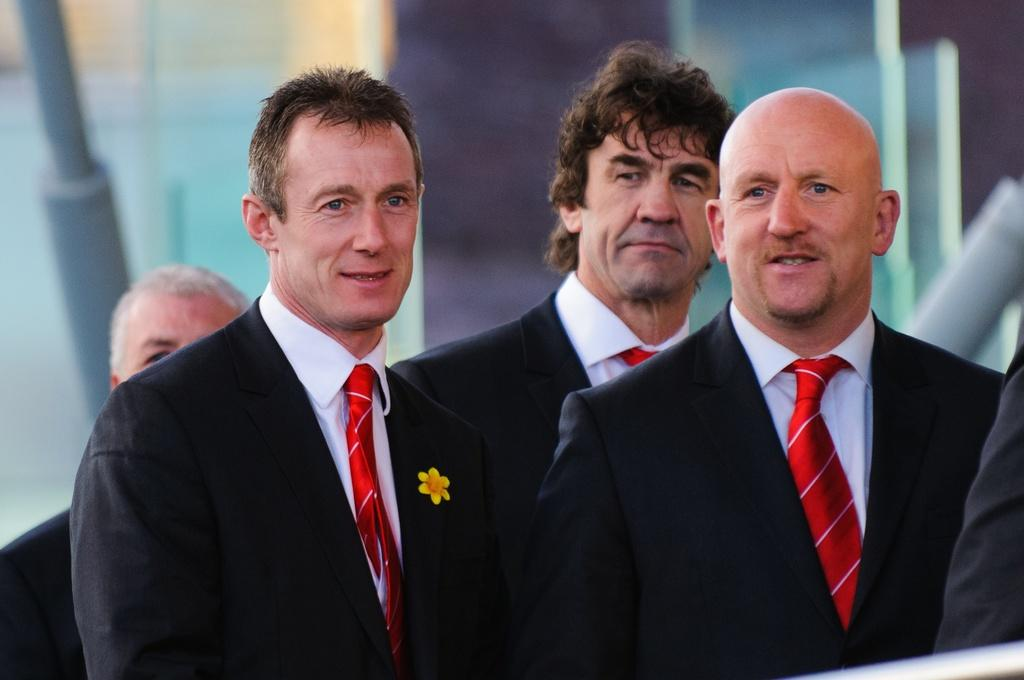How many men are in the foreground of the image? There are four men in the foreground of the image. What are the men doing in the image? The men are standing in the image. What are the men wearing in the image? The men are wearing suits in the image. What can be seen on the left side of the image in the background? There is a pole on the left side of the image in the background. How many dimes are visible on the ground in the image? There are no dimes visible on the ground in the image. What type of brake system is installed on the pole in the image? There is no brake system present on the pole in the image. 